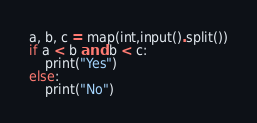Convert code to text. <code><loc_0><loc_0><loc_500><loc_500><_Python_>
a, b, c = map(int,input().split())
if a < b and b < c:
    print("Yes")
else:
    print("No")


</code> 